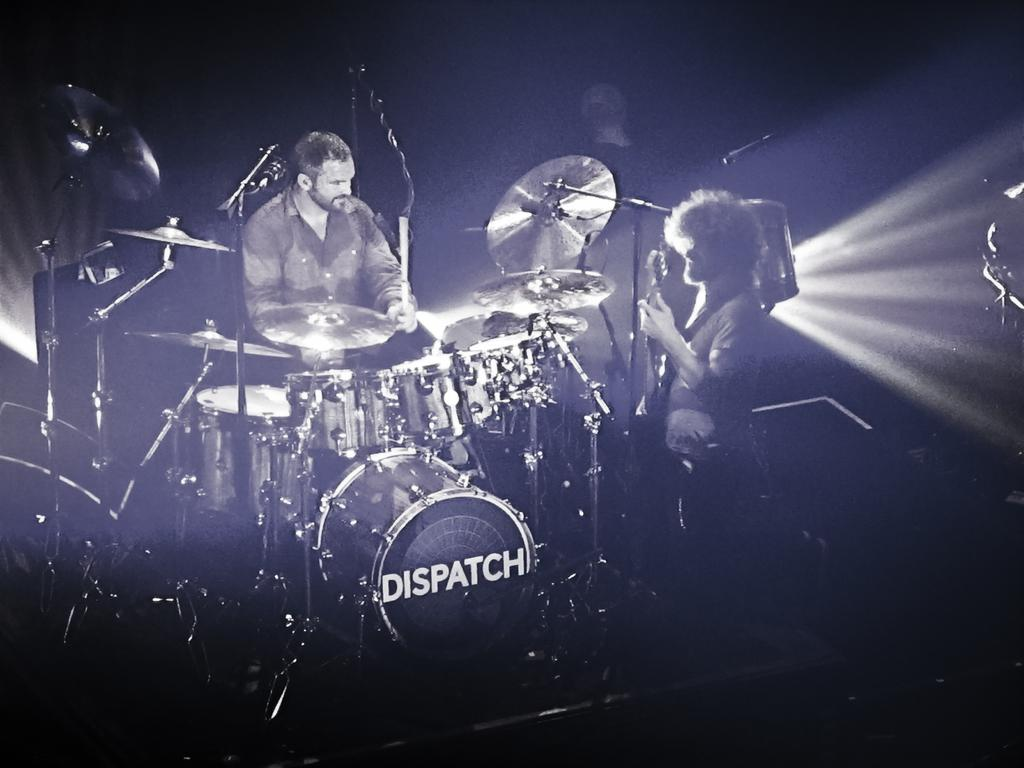How many people are in the image? There are two persons in the image. What are the two persons doing in the image? Both persons are playing musical instruments. What type of pipe can be seen in the image? There is no pipe present in the image; both persons are playing musical instruments. What fact can be learned about the chance of winning a lottery from the image? The image does not provide any information about the chance of winning a lottery, as it only shows two persons playing musical instruments. 